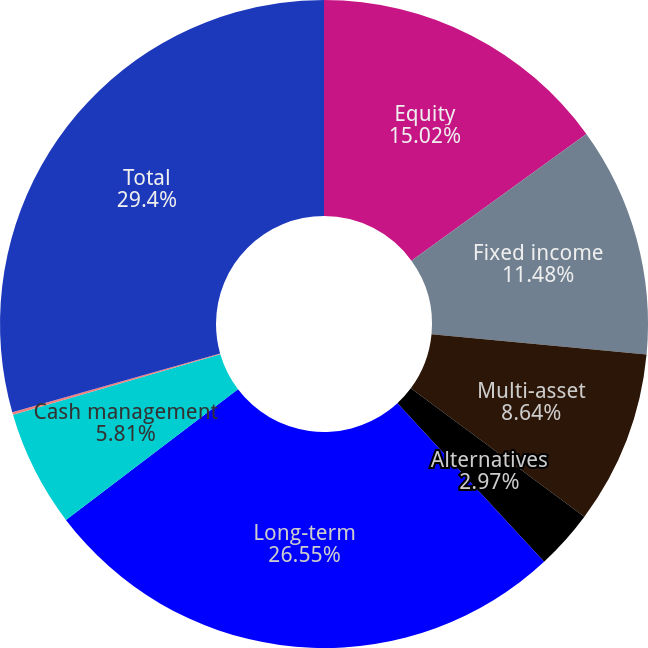Convert chart to OTSL. <chart><loc_0><loc_0><loc_500><loc_500><pie_chart><fcel>Equity<fcel>Fixed income<fcel>Multi-asset<fcel>Alternatives<fcel>Long-term<fcel>Cash management<fcel>Advisory<fcel>Total<nl><fcel>15.02%<fcel>11.48%<fcel>8.64%<fcel>2.97%<fcel>26.55%<fcel>5.81%<fcel>0.13%<fcel>29.39%<nl></chart> 